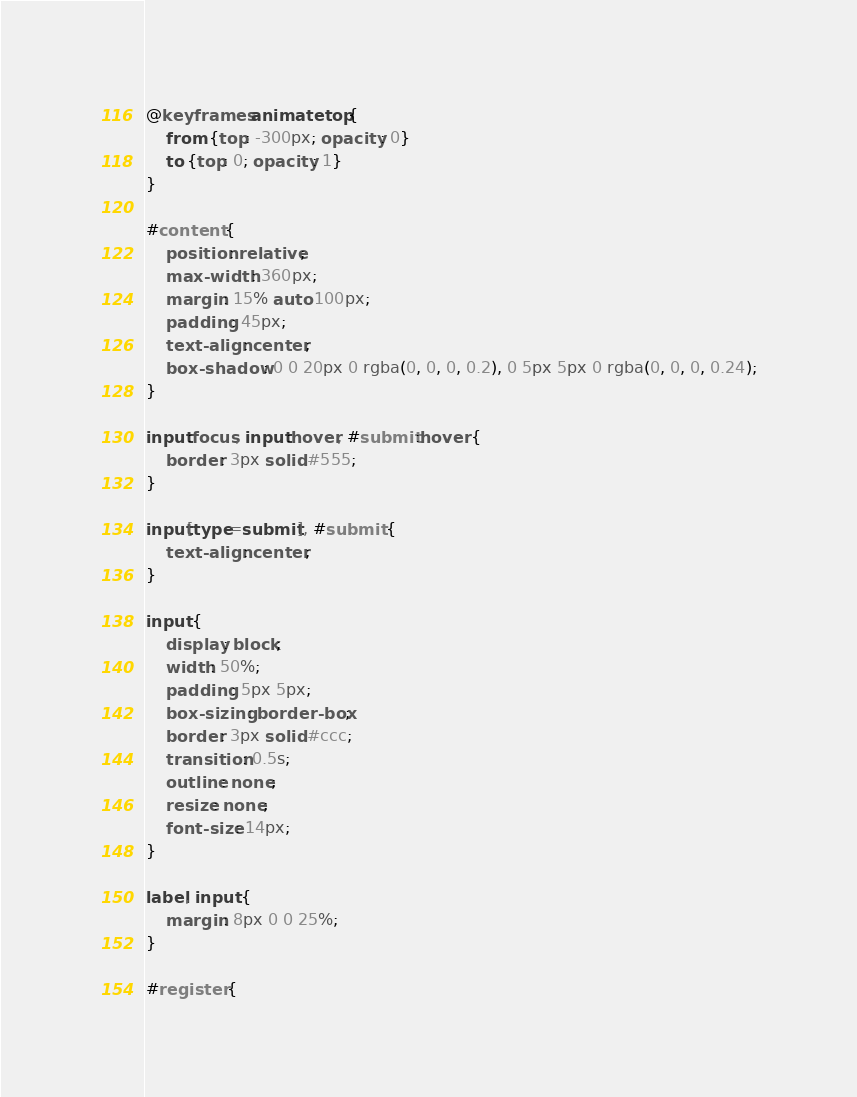Convert code to text. <code><loc_0><loc_0><loc_500><loc_500><_CSS_>@keyframes animatetop {
    from {top: -300px; opacity: 0}
    to {top: 0; opacity: 1}
}

#content { 
    position: relative;
    max-width: 360px;
    margin: 15% auto 100px;
    padding: 45px;
    text-align: center;
    box-shadow: 0 0 20px 0 rgba(0, 0, 0, 0.2), 0 5px 5px 0 rgba(0, 0, 0, 0.24);
}

input:focus, input:hover, #submit:hover {
    border: 3px solid #555;
}

input[type=submit], #submit {
    text-align: center;
}

input {  
    display: block;
    width: 50%;
    padding: 5px 5px;
    box-sizing: border-box;
    border: 3px solid #ccc;
    transition: 0.5s;
    outline: none;
    resize: none;
    font-size: 14px;
}

label, input {
    margin: 8px 0 0 25%;
}

#register {</code> 